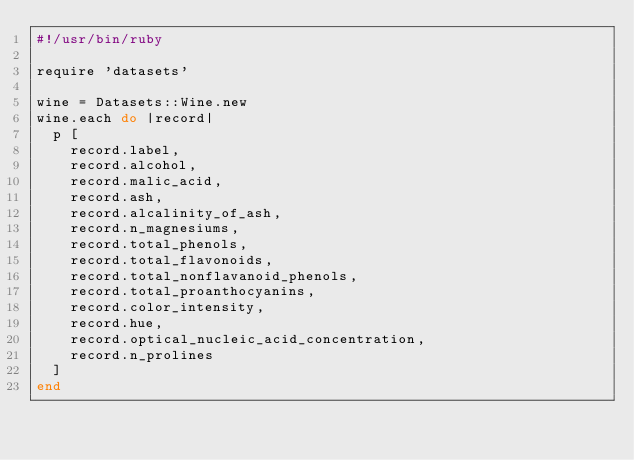<code> <loc_0><loc_0><loc_500><loc_500><_Ruby_>#!/usr/bin/ruby

require 'datasets'

wine = Datasets::Wine.new
wine.each do |record|
  p [
    record.label,
    record.alcohol,
    record.malic_acid,
    record.ash,
    record.alcalinity_of_ash,
    record.n_magnesiums,
    record.total_phenols,
    record.total_flavonoids,
    record.total_nonflavanoid_phenols,
    record.total_proanthocyanins,
    record.color_intensity,
    record.hue,
    record.optical_nucleic_acid_concentration,
    record.n_prolines
  ]
end
</code> 